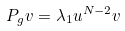Convert formula to latex. <formula><loc_0><loc_0><loc_500><loc_500>P _ { g } v = \lambda _ { 1 } u ^ { N - 2 } v</formula> 